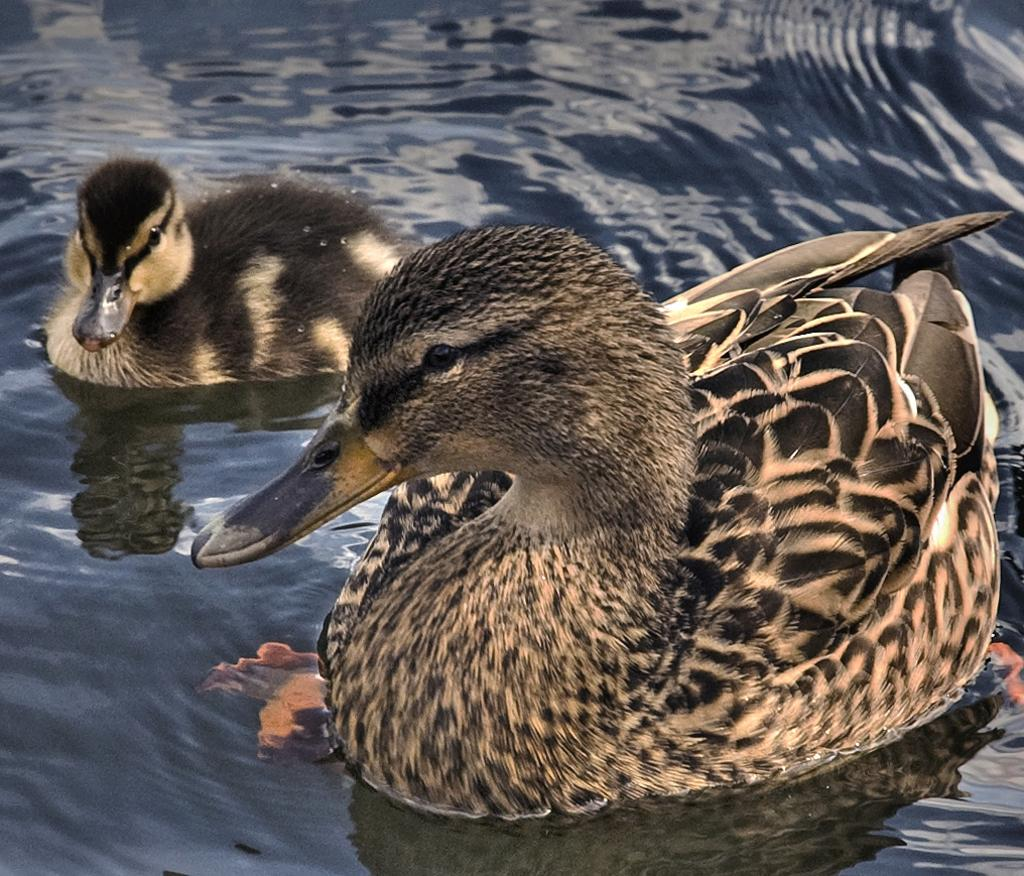What type of animal can be seen in the image? There is a duck in the image. Are there any other animals present in the image? Yes, there is a duckling in the image. Where are the duck and duckling located? Both the duck and duckling are in water. What type of pies are being served at the duck's birthday party in the image? There is no mention of pies, payment, or a birthday party in the image; it simply features a duck and a duckling in water. 